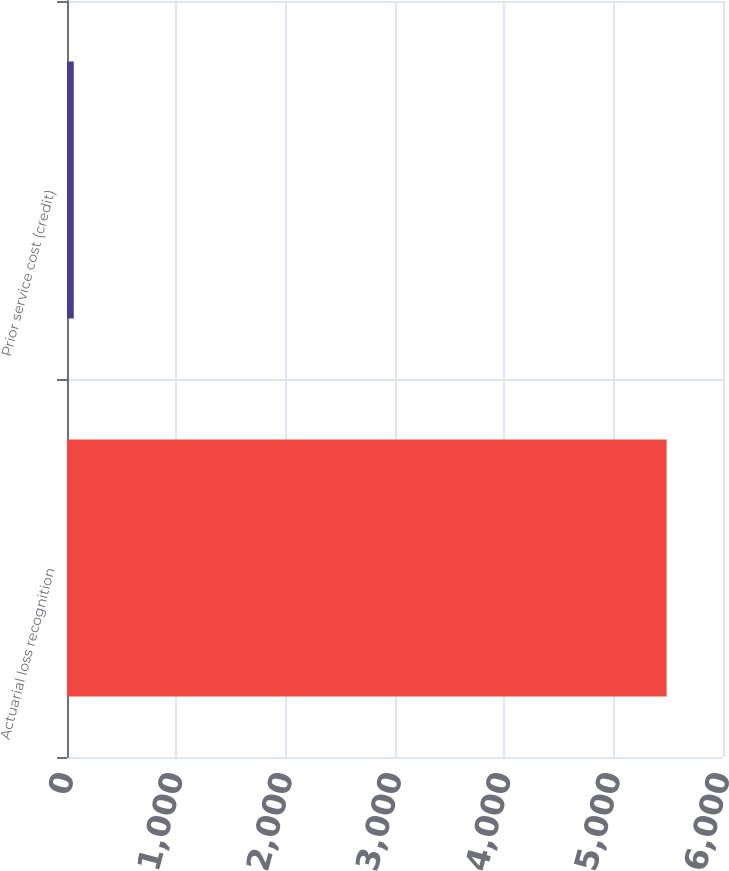Convert chart. <chart><loc_0><loc_0><loc_500><loc_500><bar_chart><fcel>Actuarial loss recognition<fcel>Prior service cost (credit)<nl><fcel>5484<fcel>62<nl></chart> 